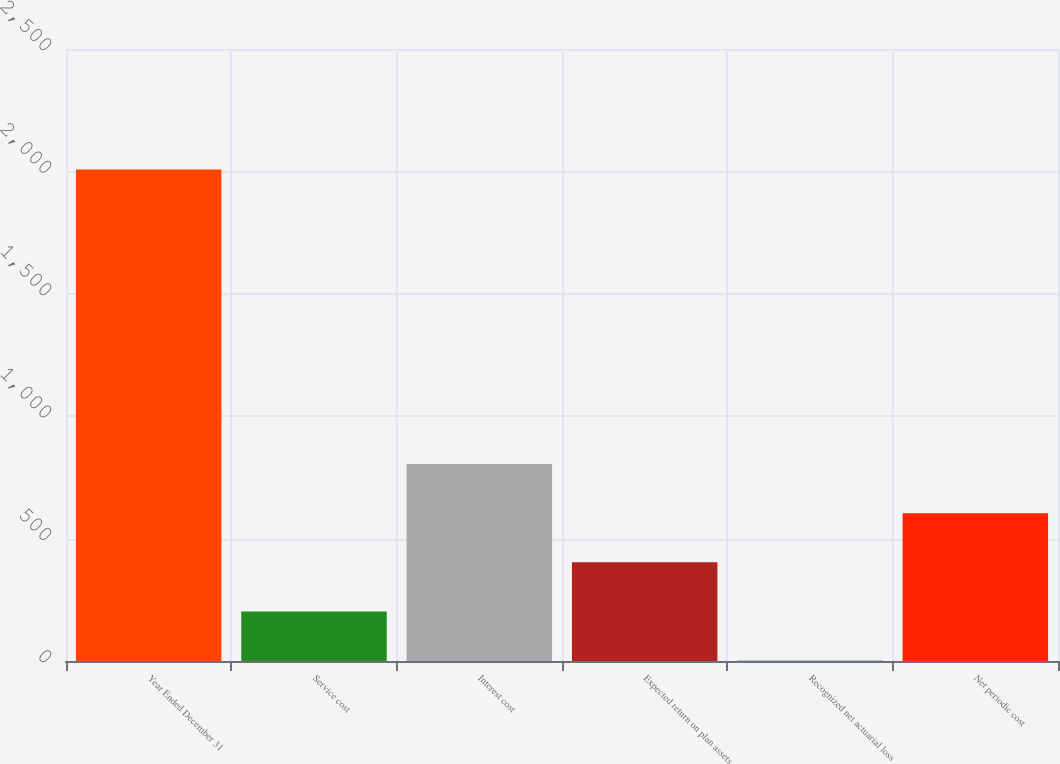<chart> <loc_0><loc_0><loc_500><loc_500><bar_chart><fcel>Year Ended December 31<fcel>Service cost<fcel>Interest cost<fcel>Expected return on plan assets<fcel>Recognized net actuarial loss<fcel>Net periodic cost<nl><fcel>2008<fcel>202.6<fcel>804.4<fcel>403.2<fcel>2<fcel>603.8<nl></chart> 